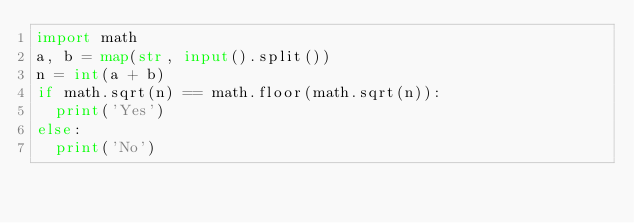<code> <loc_0><loc_0><loc_500><loc_500><_Python_>import math
a, b = map(str, input().split())
n = int(a + b)
if math.sqrt(n) == math.floor(math.sqrt(n)):
  print('Yes')
else:
  print('No')</code> 